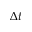Convert formula to latex. <formula><loc_0><loc_0><loc_500><loc_500>\Delta t</formula> 